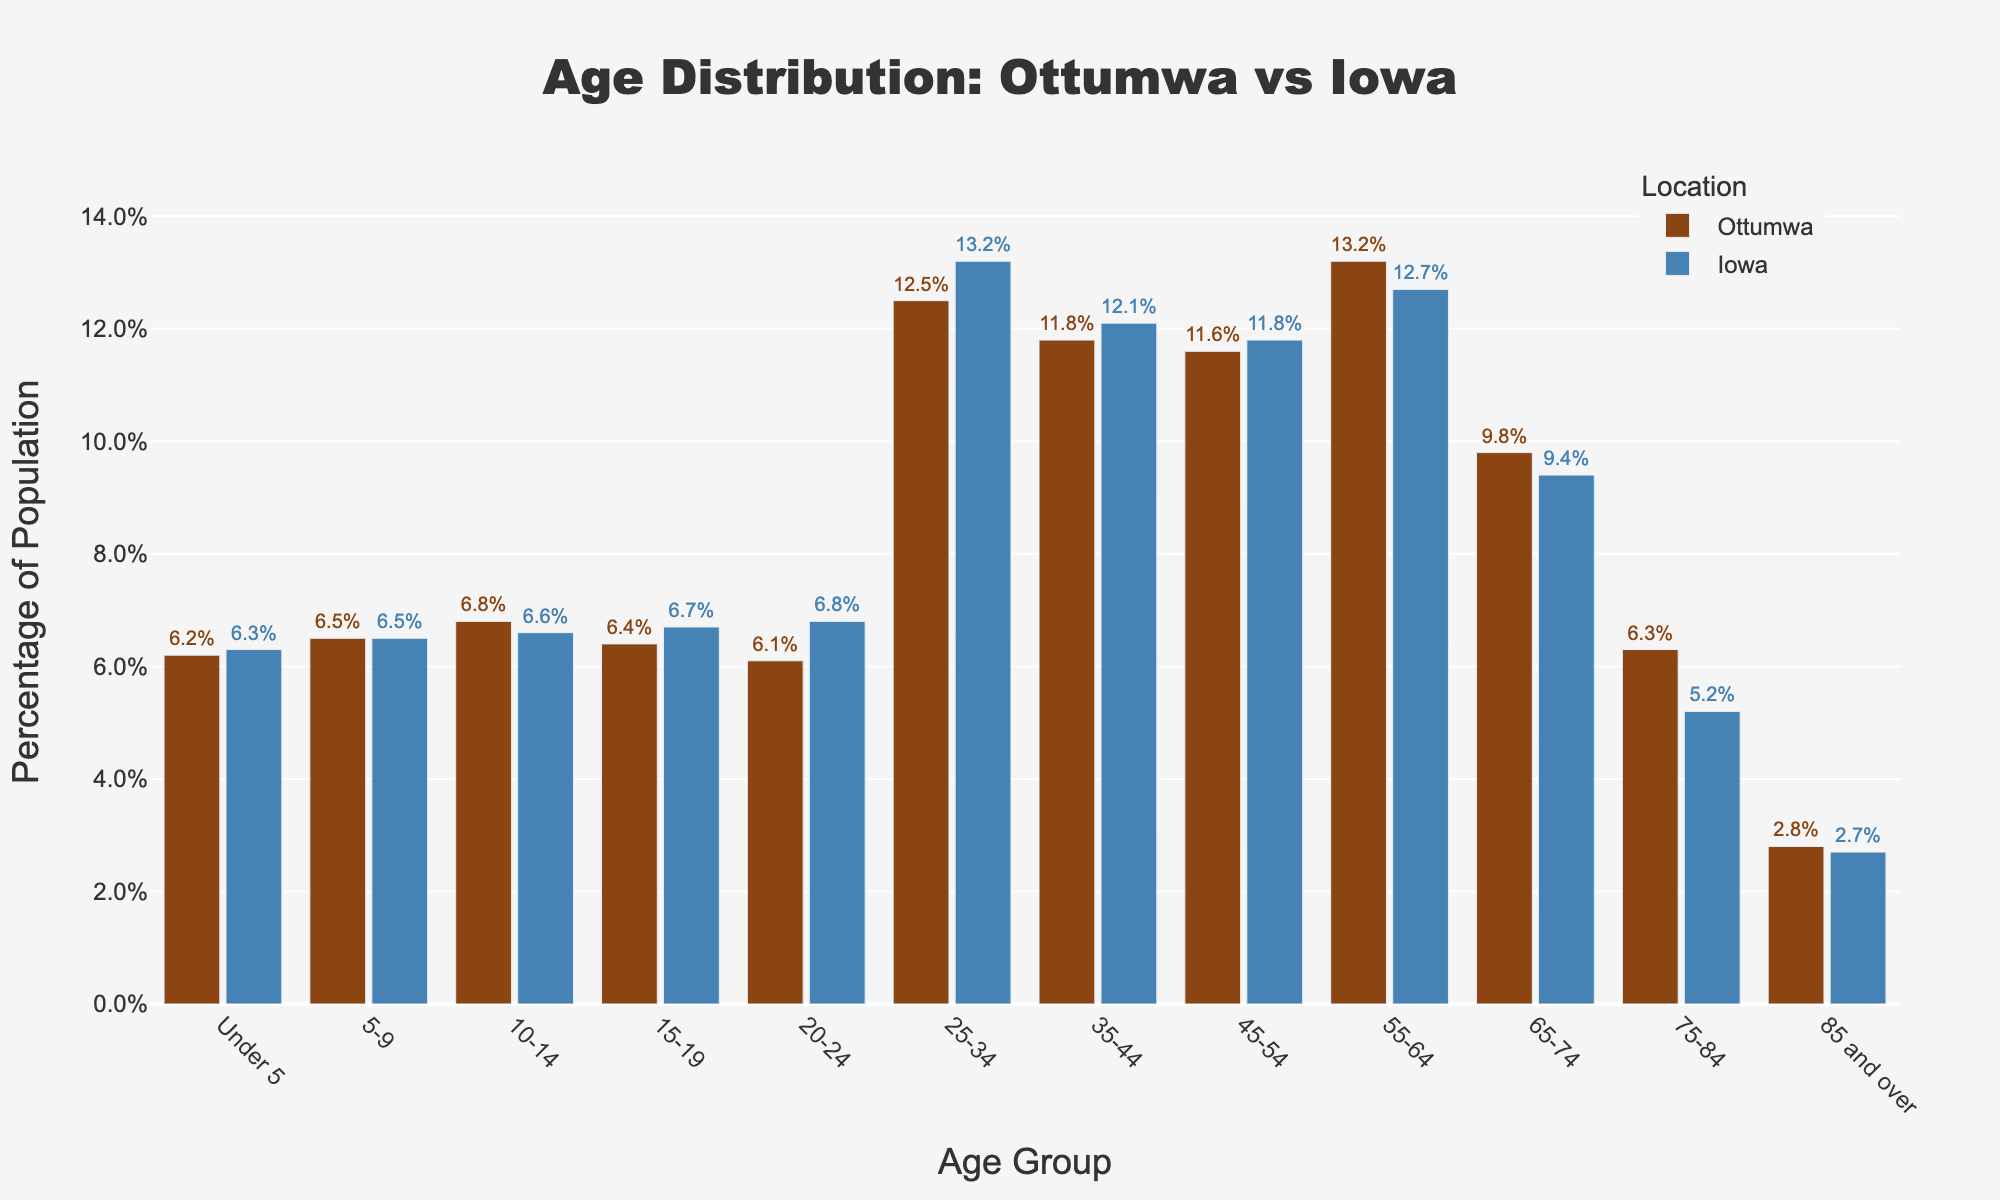What is the percentage of the population under 5 in Ottumwa compared to Iowa? The bar for the "Under 5" age group shows the values "6.2%" for Ottumwa and "6.3%" for Iowa.
Answer: 6.2% vs 6.3% How does the population percentage of the "75-84" age group in Ottumwa compare to Iowa? For the "75-84" age group, the bar chart shows values "6.3%" for Ottumwa and "5.2%" for Iowa.
Answer: 6.3% vs 5.2% Which age group in Ottumwa has the highest percentage of population? By looking at the height of the bars, the tallest bar for Ottumwa is in the "25-34" age group with a percentage of 12.5%.
Answer: 25-34 What is the visual difference in colors between the bars representing Ottumwa and Iowa? The bars representing Ottumwa are in brown, while those representing Iowa are in blue.
Answer: Brown vs Blue For the "20-24" age group, how much lower is the population percentage in Ottumwa compared to Iowa? The "20-24" age group shows 6.1% for Ottumwa and 6.8% for Iowa. The difference is 6.8% - 6.1% = 0.7%.
Answer: 0.7% Which age group has a higher population percentage in Ottumwa than in Iowa? The age groups "55-64" and "75-84" show a higher percentage in Ottumwa (13.2% and 6.3%) compared to Iowa (12.7% and 5.2%).
Answer: 55-64 and 75-84 What is the sum of the percentages for the "Under 5" and "85 and over" age groups in Ottumwa? The values for these groups are 6.2% and 2.8% respectively. Adding them gives 6.2% + 2.8% = 9.0%.
Answer: 9.0% Which age group has the smallest difference in population percentage between Ottumwa and Iowa? The "5-9" age group has both Ottumwa and Iowa at 6.5%, showing zero difference.
Answer: 5-9 Does any age group in Ottumwa exactly match the state average? By examining the bars, the "5-9" age group shows 6.5% for both Ottumwa and Iowa.
Answer: Yes, 5-9 age group 